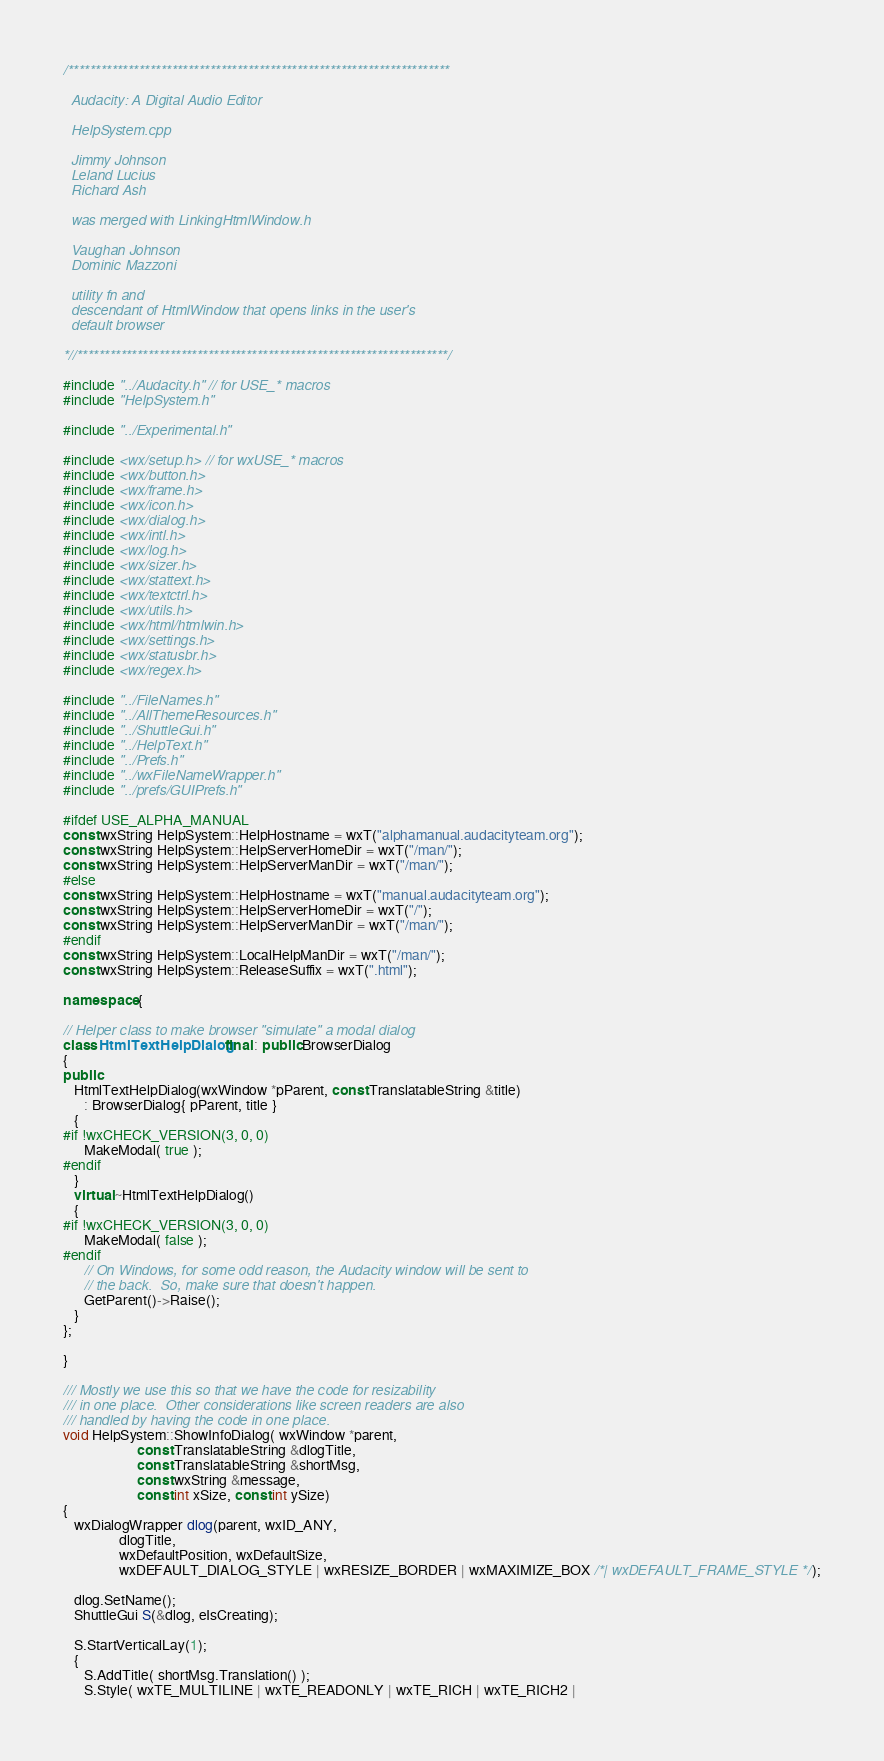<code> <loc_0><loc_0><loc_500><loc_500><_C++_>/**********************************************************************

  Audacity: A Digital Audio Editor

  HelpSystem.cpp

  Jimmy Johnson
  Leland Lucius
  Richard Ash

  was merged with LinkingHtmlWindow.h

  Vaughan Johnson
  Dominic Mazzoni

  utility fn and
  descendant of HtmlWindow that opens links in the user's
  default browser

*//********************************************************************/

#include "../Audacity.h" // for USE_* macros
#include "HelpSystem.h"

#include "../Experimental.h"

#include <wx/setup.h> // for wxUSE_* macros
#include <wx/button.h>
#include <wx/frame.h>
#include <wx/icon.h>
#include <wx/dialog.h>
#include <wx/intl.h>
#include <wx/log.h>
#include <wx/sizer.h>
#include <wx/stattext.h>
#include <wx/textctrl.h>
#include <wx/utils.h>
#include <wx/html/htmlwin.h>
#include <wx/settings.h>
#include <wx/statusbr.h>
#include <wx/regex.h>

#include "../FileNames.h"
#include "../AllThemeResources.h"
#include "../ShuttleGui.h"
#include "../HelpText.h"
#include "../Prefs.h"
#include "../wxFileNameWrapper.h"
#include "../prefs/GUIPrefs.h"

#ifdef USE_ALPHA_MANUAL
const wxString HelpSystem::HelpHostname = wxT("alphamanual.audacityteam.org");
const wxString HelpSystem::HelpServerHomeDir = wxT("/man/");
const wxString HelpSystem::HelpServerManDir = wxT("/man/");
#else
const wxString HelpSystem::HelpHostname = wxT("manual.audacityteam.org");
const wxString HelpSystem::HelpServerHomeDir = wxT("/");
const wxString HelpSystem::HelpServerManDir = wxT("/man/");
#endif
const wxString HelpSystem::LocalHelpManDir = wxT("/man/");
const wxString HelpSystem::ReleaseSuffix = wxT(".html");

namespace {

// Helper class to make browser "simulate" a modal dialog
class HtmlTextHelpDialog final : public BrowserDialog
{
public:
   HtmlTextHelpDialog(wxWindow *pParent, const TranslatableString &title)
      : BrowserDialog{ pParent, title }
   {
#if !wxCHECK_VERSION(3, 0, 0)
      MakeModal( true );
#endif
   }
   virtual ~HtmlTextHelpDialog()
   {
#if !wxCHECK_VERSION(3, 0, 0)
      MakeModal( false );
#endif
      // On Windows, for some odd reason, the Audacity window will be sent to
      // the back.  So, make sure that doesn't happen.
      GetParent()->Raise();
   }
};

}

/// Mostly we use this so that we have the code for resizability
/// in one place.  Other considerations like screen readers are also
/// handled by having the code in one place.
void HelpSystem::ShowInfoDialog( wxWindow *parent,
                     const TranslatableString &dlogTitle,
                     const TranslatableString &shortMsg,
                     const wxString &message,
                     const int xSize, const int ySize)
{
   wxDialogWrapper dlog(parent, wxID_ANY,
                dlogTitle,
                wxDefaultPosition, wxDefaultSize,
                wxDEFAULT_DIALOG_STYLE | wxRESIZE_BORDER | wxMAXIMIZE_BOX /*| wxDEFAULT_FRAME_STYLE */);

   dlog.SetName();
   ShuttleGui S(&dlog, eIsCreating);

   S.StartVerticalLay(1);
   {
      S.AddTitle( shortMsg.Translation() );
      S.Style( wxTE_MULTILINE | wxTE_READONLY | wxTE_RICH | wxTE_RICH2 |</code> 